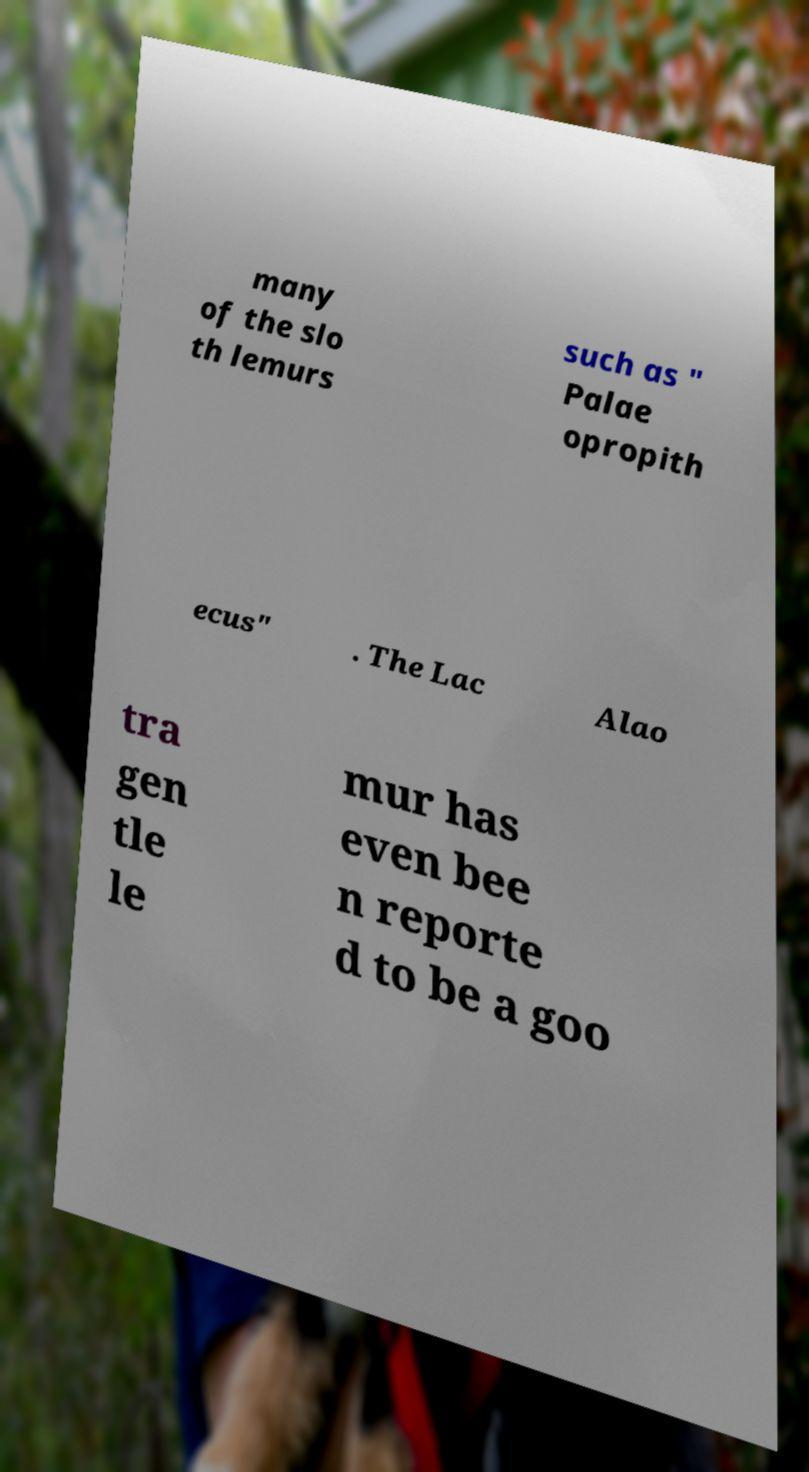I need the written content from this picture converted into text. Can you do that? many of the slo th lemurs such as " Palae opropith ecus" . The Lac Alao tra gen tle le mur has even bee n reporte d to be a goo 